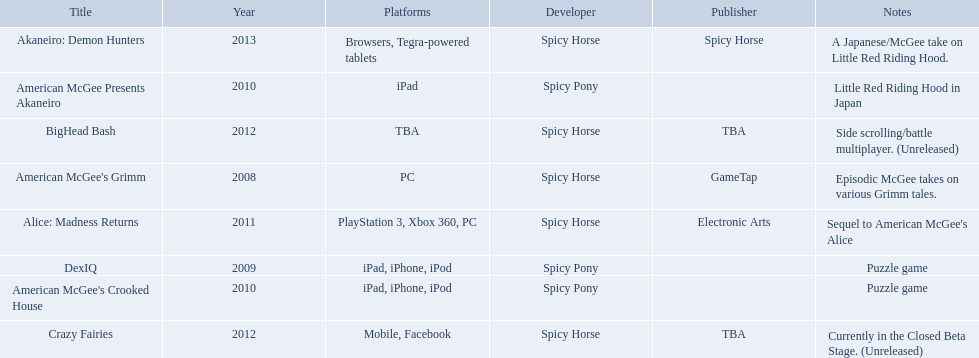What are all the titles of games published? American McGee's Grimm, DexIQ, American McGee Presents Akaneiro, American McGee's Crooked House, Alice: Madness Returns, BigHead Bash, Crazy Fairies, Akaneiro: Demon Hunters. What are all the names of the publishers? GameTap, , , , Electronic Arts, TBA, TBA, Spicy Horse. What is the published game title that corresponds to electronic arts? Alice: Madness Returns. Help me parse the entirety of this table. {'header': ['Title', 'Year', 'Platforms', 'Developer', 'Publisher', 'Notes'], 'rows': [['Akaneiro: Demon Hunters', '2013', 'Browsers, Tegra-powered tablets', 'Spicy Horse', 'Spicy Horse', 'A Japanese/McGee take on Little Red Riding Hood.'], ['American McGee Presents Akaneiro', '2010', 'iPad', 'Spicy Pony', '', 'Little Red Riding Hood in Japan'], ['BigHead Bash', '2012', 'TBA', 'Spicy Horse', 'TBA', 'Side scrolling/battle multiplayer. (Unreleased)'], ["American McGee's Grimm", '2008', 'PC', 'Spicy Horse', 'GameTap', 'Episodic McGee takes on various Grimm tales.'], ['Alice: Madness Returns', '2011', 'PlayStation 3, Xbox 360, PC', 'Spicy Horse', 'Electronic Arts', "Sequel to American McGee's Alice"], ['DexIQ', '2009', 'iPad, iPhone, iPod', 'Spicy Pony', '', 'Puzzle game'], ["American McGee's Crooked House", '2010', 'iPad, iPhone, iPod', 'Spicy Pony', '', 'Puzzle game'], ['Crazy Fairies', '2012', 'Mobile, Facebook', 'Spicy Horse', 'TBA', 'Currently in the Closed Beta Stage. (Unreleased)']]} What are all of the game titles? American McGee's Grimm, DexIQ, American McGee Presents Akaneiro, American McGee's Crooked House, Alice: Madness Returns, BigHead Bash, Crazy Fairies, Akaneiro: Demon Hunters. Which developer developed a game in 2011? Spicy Horse. Who published this game in 2011 Electronic Arts. What was the name of this published game in 2011? Alice: Madness Returns. 